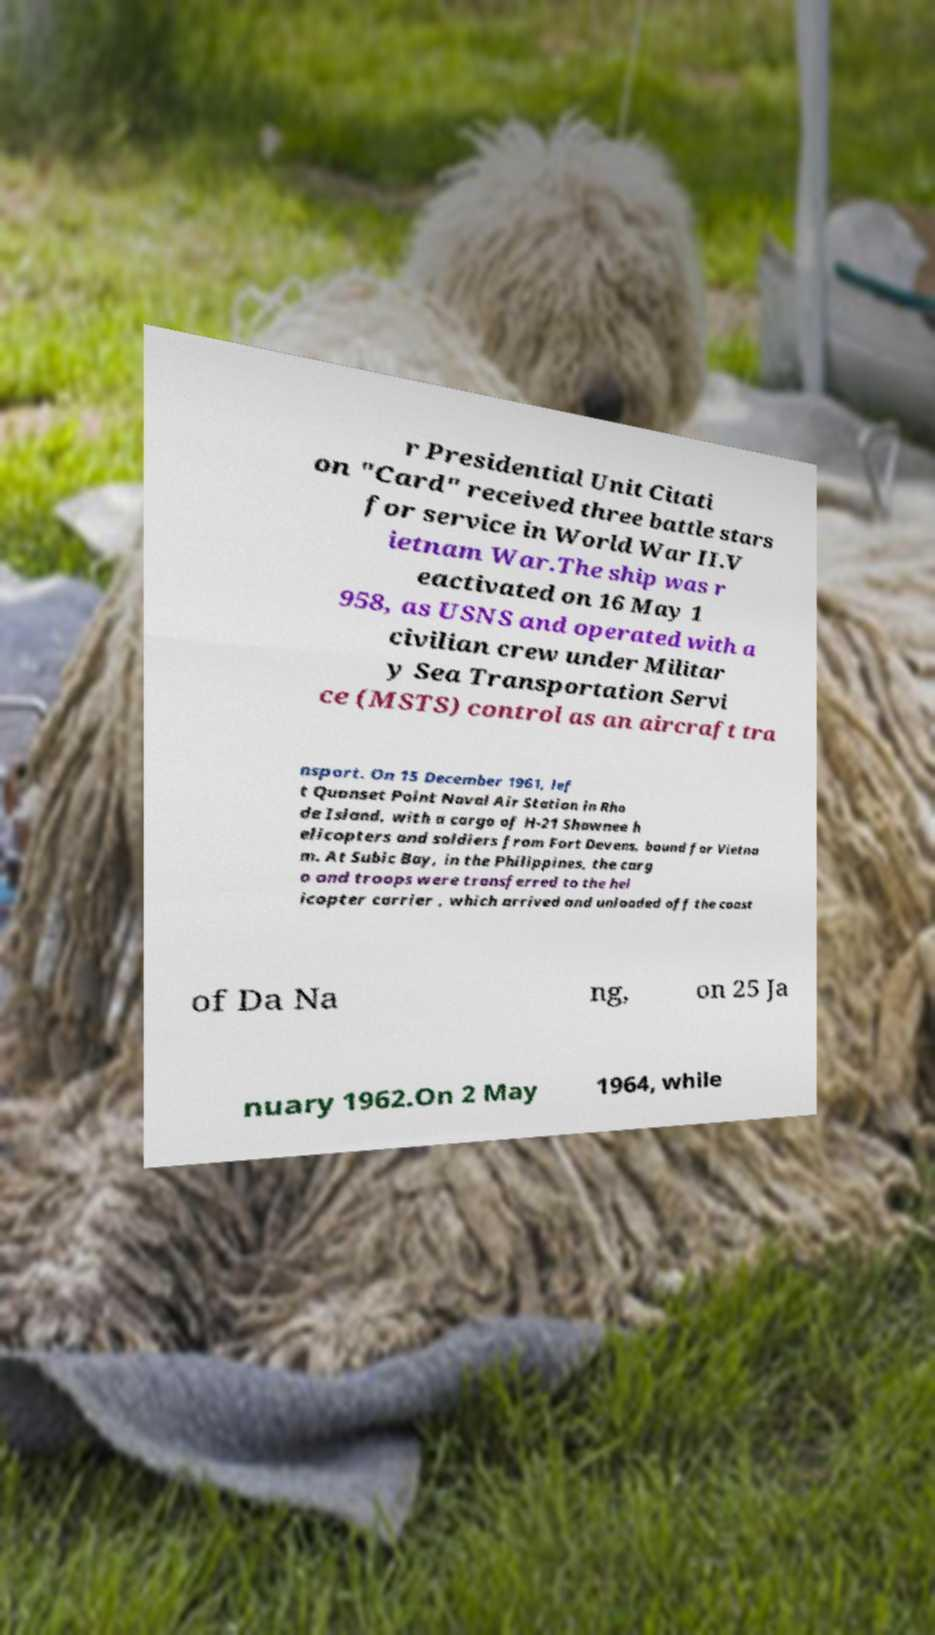Could you extract and type out the text from this image? r Presidential Unit Citati on "Card" received three battle stars for service in World War II.V ietnam War.The ship was r eactivated on 16 May 1 958, as USNS and operated with a civilian crew under Militar y Sea Transportation Servi ce (MSTS) control as an aircraft tra nsport. On 15 December 1961, lef t Quonset Point Naval Air Station in Rho de Island, with a cargo of H-21 Shawnee h elicopters and soldiers from Fort Devens, bound for Vietna m. At Subic Bay, in the Philippines, the carg o and troops were transferred to the hel icopter carrier , which arrived and unloaded off the coast of Da Na ng, on 25 Ja nuary 1962.On 2 May 1964, while 